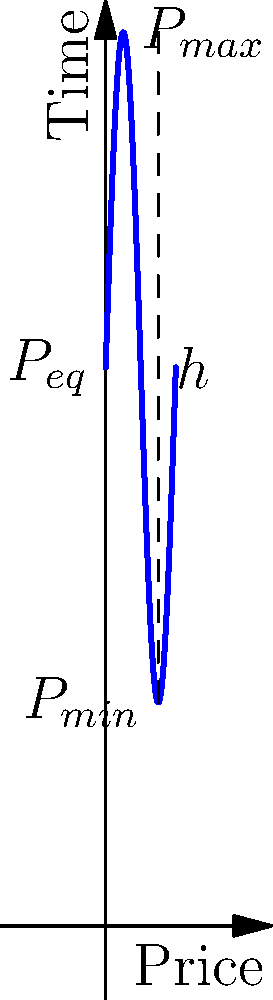In a pendulum-like price oscillation model, the price swings between a maximum of $80 and a minimum of $20, with an equilibrium price of $50. If we consider the price as a particle with a mass of 1 unit, calculate the change in potential energy when the price moves from its minimum to its maximum position. Assume the gravitational acceleration g = 9.8 m/s². To solve this problem, we'll follow these steps:

1) The formula for gravitational potential energy is:
   $$PE = mgh$$
   where m is mass, g is gravitational acceleration, and h is height difference.

2) In this case:
   m = 1 unit (given)
   g = 9.8 m/s² (given)
   h = $80 - $20 = $60 (price difference between max and min)

3) Substituting these values into the formula:
   $$PE = 1 \times 9.8 \times 60 = 588$$

4) The units for this energy would be dollar-meters per second squared ($⋅m/s²).

5) Since we're dealing with an abstract model where price is treated as height, we can simplify the units to just energy units, which we'll call "price energy units" or PEU.

Therefore, the change in potential energy when the price moves from its minimum to its maximum position is 588 PEU.
Answer: 588 PEU 